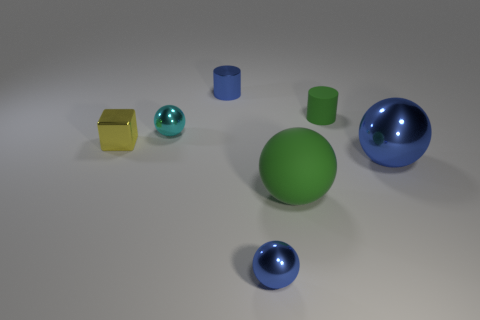Add 1 large cyan shiny balls. How many objects exist? 8 Subtract all cyan balls. How many balls are left? 3 Subtract all blocks. How many objects are left? 6 Subtract all blue balls. How many balls are left? 2 Subtract 0 red balls. How many objects are left? 7 Subtract 2 balls. How many balls are left? 2 Subtract all green cylinders. Subtract all red cubes. How many cylinders are left? 1 Subtract all red cylinders. How many green balls are left? 1 Subtract all metallic cylinders. Subtract all tiny metallic things. How many objects are left? 2 Add 1 big blue shiny objects. How many big blue shiny objects are left? 2 